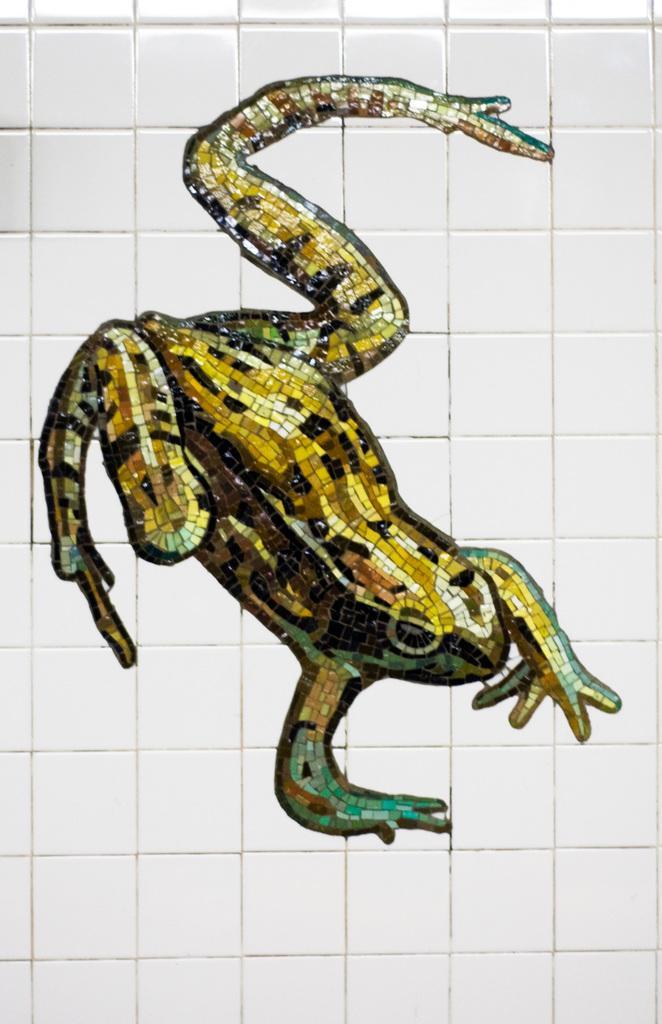Describe this image in one or two sentences. This is a zoomed in picture. In the center we can see a wall art of a frog on the white color wall. 